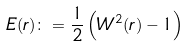<formula> <loc_0><loc_0><loc_500><loc_500>E ( r ) \colon = \frac { 1 } { 2 } \left ( W ^ { 2 } ( r ) - 1 \right )</formula> 